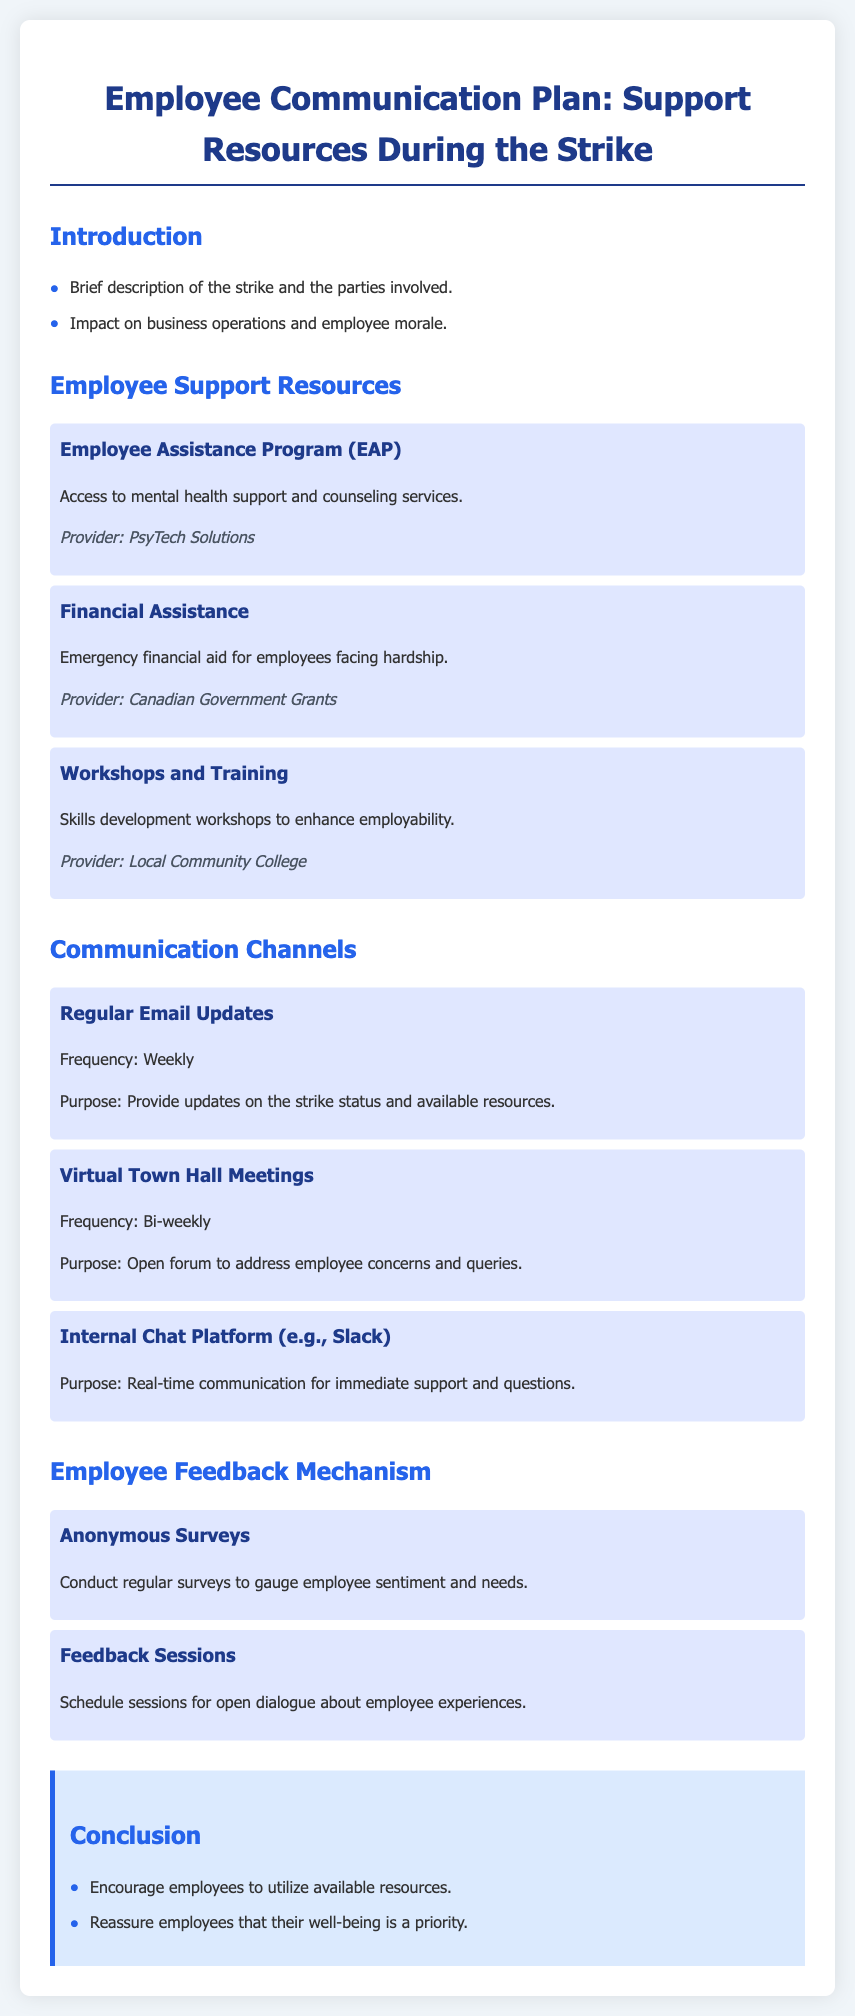what is the name of the support program for mental health? The document lists the Employee Assistance Program (EAP) as the support program for mental health.
Answer: Employee Assistance Program (EAP) who is the provider of the financial assistance? The document states that the provider of the financial assistance is the Canadian Government Grants.
Answer: Canadian Government Grants how frequently will virtual town hall meetings occur? The document specifies that virtual town hall meetings will occur bi-weekly.
Answer: Bi-weekly what type of feedback mechanism is mentioned in the document? The document mentions anonymous surveys as one of the feedback mechanisms.
Answer: Anonymous Surveys what is the purpose of the regular email updates? According to the document, the purpose of the regular email updates is to provide updates on the strike status and available resources.
Answer: Provide updates on the strike status and available resources which organization provides the workshops and training? The document indicates that the local community college provides the workshops and training.
Answer: Local Community College what is the main concern addressed in the conclusion? The conclusion emphasizes that employees' well-being is a priority.
Answer: Employees' well-being is a priority how are employee concerns addressed in the communication plan? The document describes virtual town hall meetings as a platform to address employee concerns.
Answer: Virtual town hall meetings what is offered to enhance employability? The document states that skills development workshops are offered to enhance employability.
Answer: Skills development workshops 